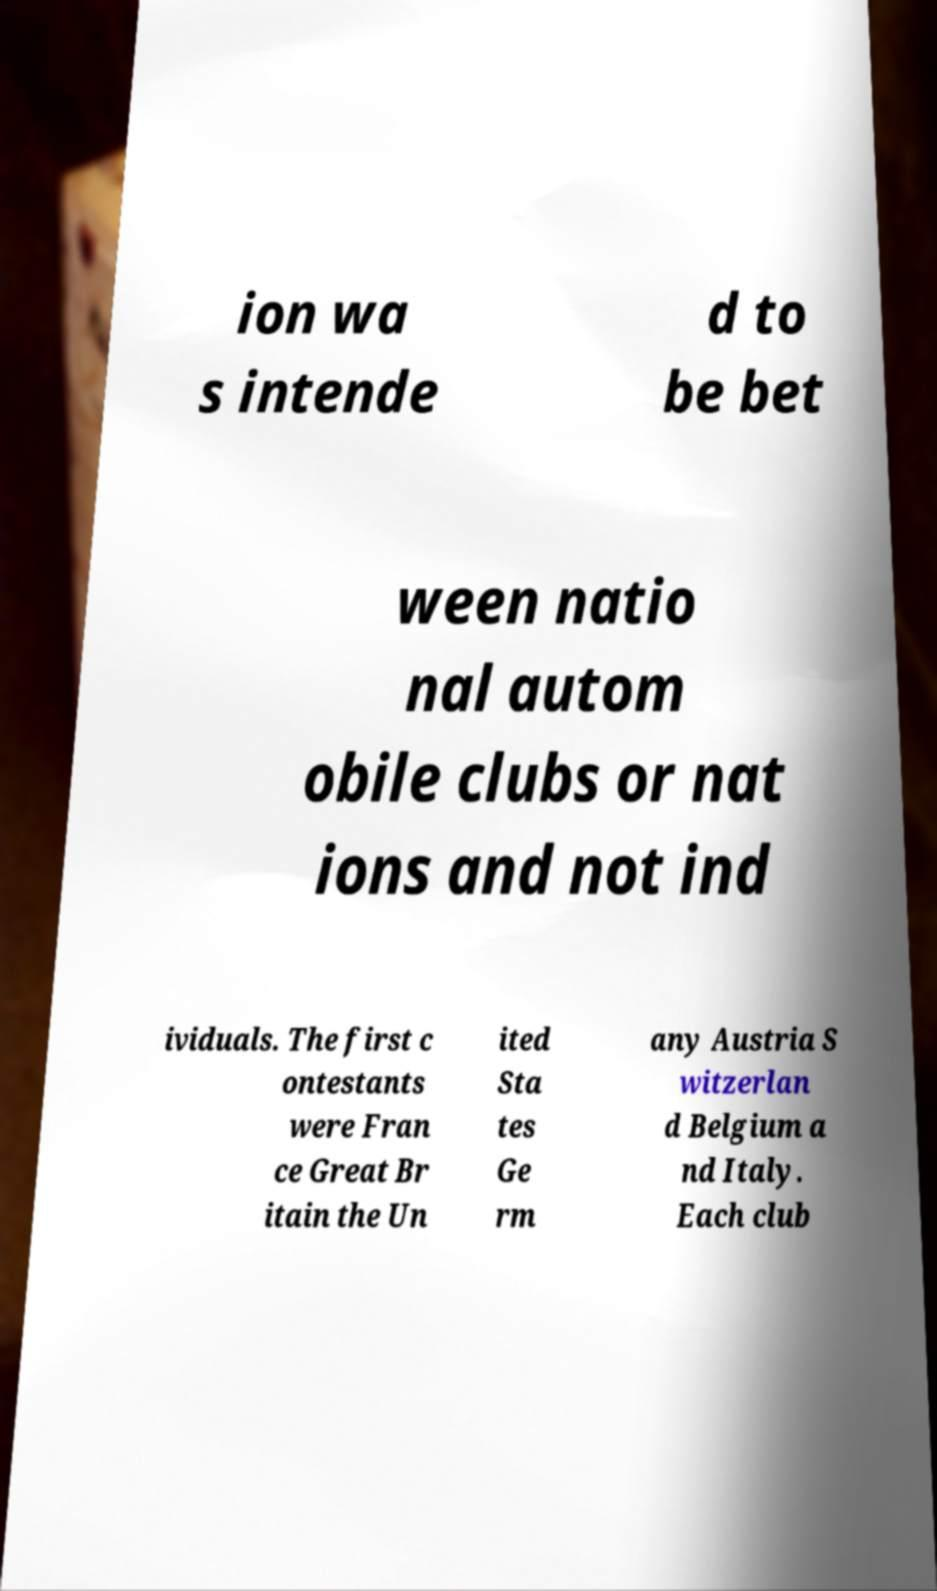What messages or text are displayed in this image? I need them in a readable, typed format. ion wa s intende d to be bet ween natio nal autom obile clubs or nat ions and not ind ividuals. The first c ontestants were Fran ce Great Br itain the Un ited Sta tes Ge rm any Austria S witzerlan d Belgium a nd Italy. Each club 